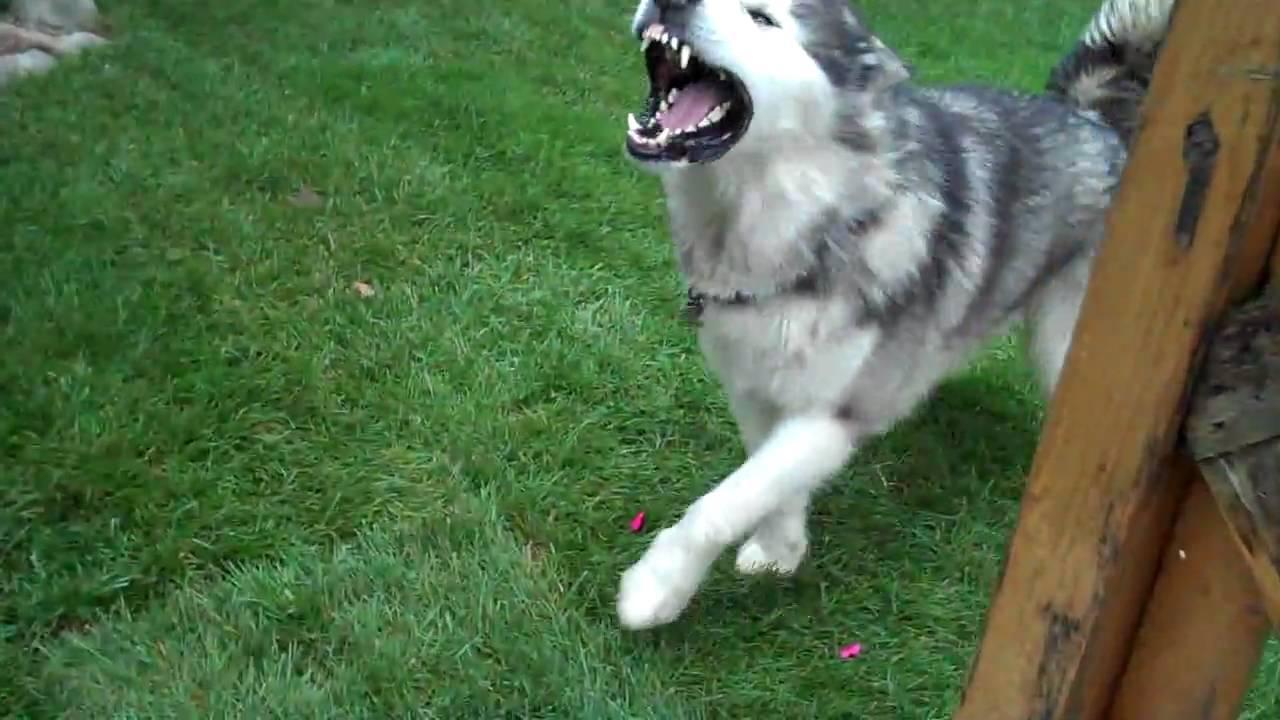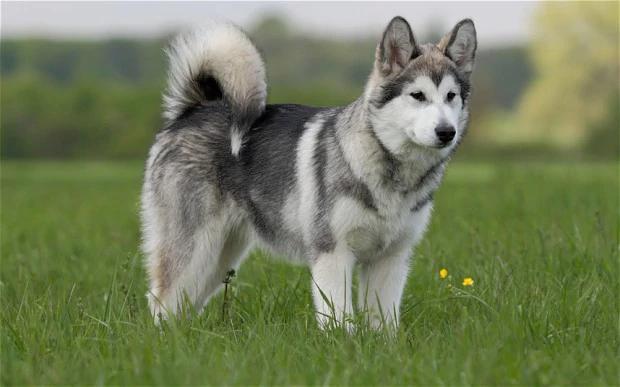The first image is the image on the left, the second image is the image on the right. Analyze the images presented: Is the assertion "There are two dogs on grass." valid? Answer yes or no. Yes. The first image is the image on the left, the second image is the image on the right. Evaluate the accuracy of this statement regarding the images: "The husky is holding something in its mouth.". Is it true? Answer yes or no. No. 